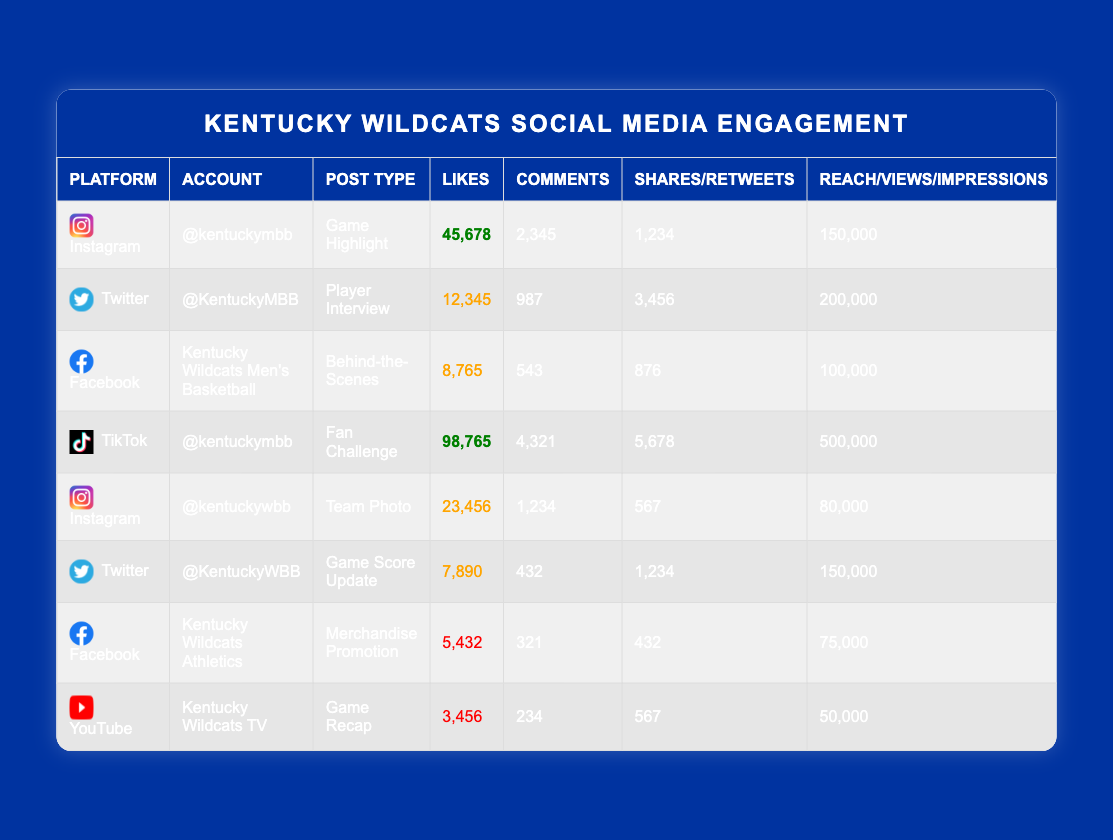What is the highest number of likes received on a post? The likes can be found in the Likes column. Reviewing the posts, "@kentuckymbb" on TikTok received the highest likes of 98,765.
Answer: 98765 Which platform had the most engagement in terms of reach/views/impressions? The reach/views/impressions can be found in the respective column. Adding them gives: Instagram 150,000 + Twitter 200,000 + Facebook 100,000 + TikTok 500,000 + Instagram 80,000 + Twitter 150,000 + Facebook 75,000 + YouTube 50,000 = 1,305,000. TikTok contributed the most with 500,000.
Answer: TikTok Did Kentucky Wildcats Men's Basketball have any post that reached more than 150,000 impressions? The account '@KentuckyMBB' had the Twitter post with 200,000 impressions, which is over 150,000.
Answer: Yes What is the average number of likes for posts on the Facebook platform? The Facebook posts received likes of 8,765, 5,432. Summing the likes gives 8,765 + 5,432 = 14,197, and dividing by the number of posts (2) results in an average of 14,197 / 2 = 7,098.5.
Answer: 7098.5 Which account had the lowest engagement in terms of total interactions (likes + comments + shares/retweets) and what was that total? Calculate total interactions for all accounts. The account 'Kentucky Wildcats TV' had likes 3,456, comments 234, shares 567, totaling 4,257, which is the lowest when compared against other accounts.
Answer: 4257 How many posts did '@kentuckymbb' have that had more than 40,000 likes? Checking the likes for '@kentuckymbb', we see one post on TikTok with 98,765 likes and one post on Instagram with 45,678 likes, making a total of 2 posts over 40,000 likes.
Answer: 2 What was the content type with the highest number of shares across all accounts? The shares found in each post are 1,234, 3,456, 876, 5,678, 567, 1,234, 432, and 567. The TikTok post by '@kentuckymbb' with 5,678 shares has the highest total.
Answer: Fan Challenge Is there a post on Instagram that received more comments than the average across all posts? Calculate the total comments: 2,345 + 987 + 543 + 4,321 + 1,234 + 432 + 321 + 234 = 10, 012. The average comments are 10,012 / 8 = 1,251.5. The Instagram post by '@kentuckymbb' received 2,345 comments, which is greater than the average.
Answer: Yes 